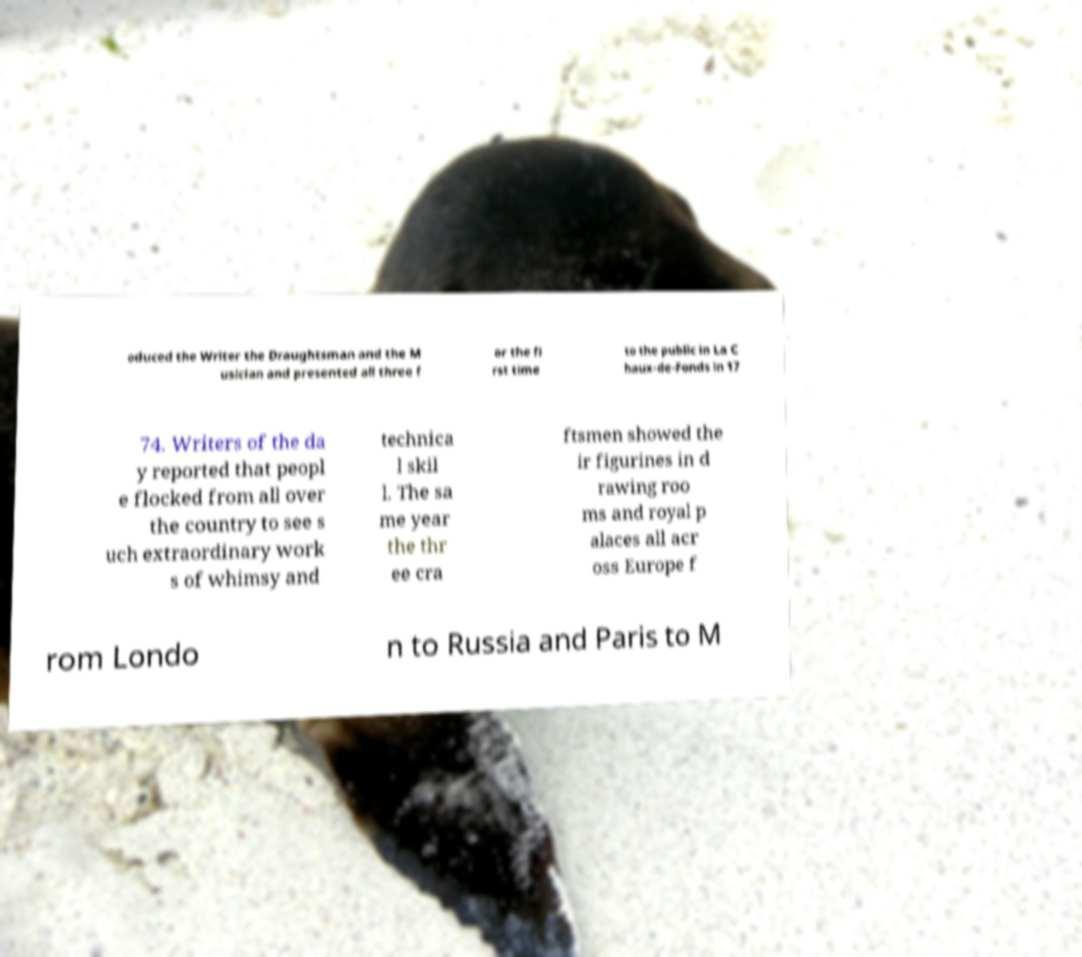For documentation purposes, I need the text within this image transcribed. Could you provide that? oduced the Writer the Draughtsman and the M usician and presented all three f or the fi rst time to the public in La C haux-de-Fonds in 17 74. Writers of the da y reported that peopl e flocked from all over the country to see s uch extraordinary work s of whimsy and technica l skil l. The sa me year the thr ee cra ftsmen showed the ir figurines in d rawing roo ms and royal p alaces all acr oss Europe f rom Londo n to Russia and Paris to M 